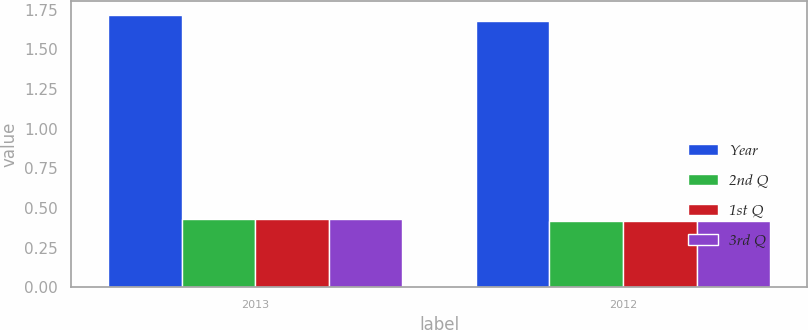Convert chart. <chart><loc_0><loc_0><loc_500><loc_500><stacked_bar_chart><ecel><fcel>2013<fcel>2012<nl><fcel>Year<fcel>1.72<fcel>1.68<nl><fcel>2nd Q<fcel>0.43<fcel>0.42<nl><fcel>1st Q<fcel>0.43<fcel>0.42<nl><fcel>3rd Q<fcel>0.43<fcel>0.42<nl></chart> 